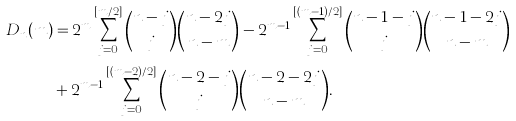Convert formula to latex. <formula><loc_0><loc_0><loc_500><loc_500>D _ { n } ( m ) & = 2 ^ { m } \sum _ { j = 0 } ^ { [ m / 2 ] } \binom { n - j } { j } \binom { n - 2 j } { n - m } - 2 ^ { m - 1 } \sum _ { j = 0 } ^ { [ ( m - 1 ) / 2 ] } \binom { n - 1 - j } { j } \binom { n - 1 - 2 j } { n - m } \\ & + 2 ^ { m - 1 } \sum _ { j = 0 } ^ { [ ( m - 2 ) / 2 ] } \binom { n - 2 - j } { j } \binom { n - 2 - 2 j } { n - m } .</formula> 